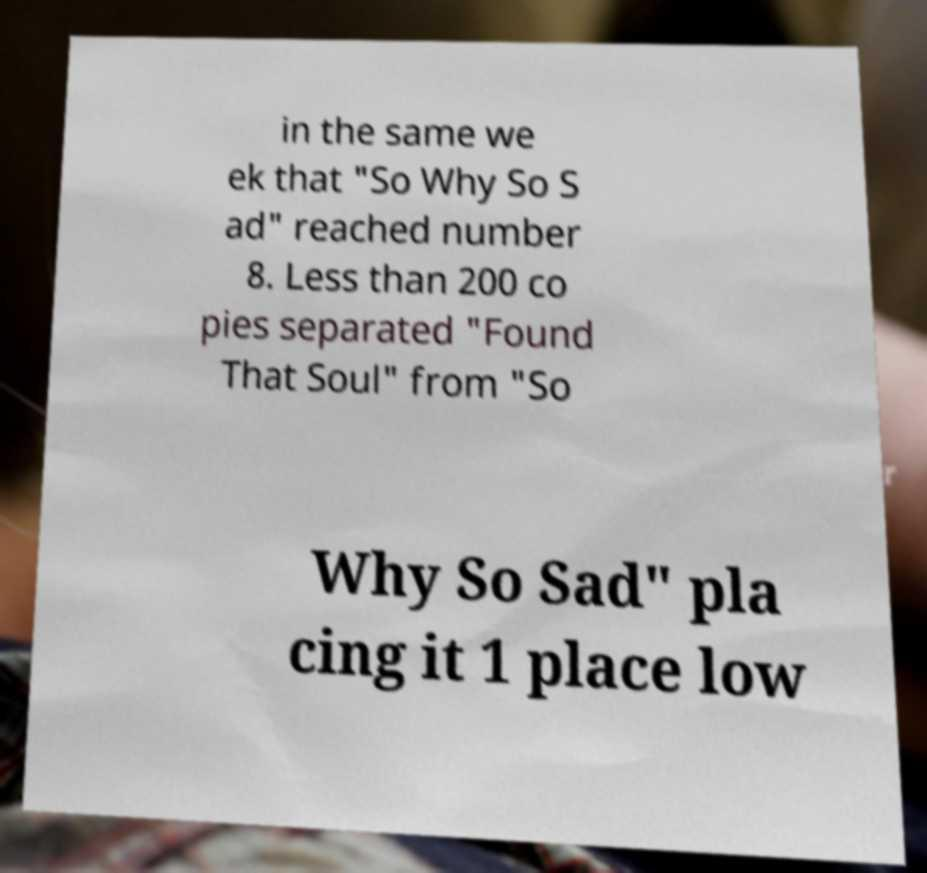What messages or text are displayed in this image? I need them in a readable, typed format. in the same we ek that "So Why So S ad" reached number 8. Less than 200 co pies separated "Found That Soul" from "So Why So Sad" pla cing it 1 place low 